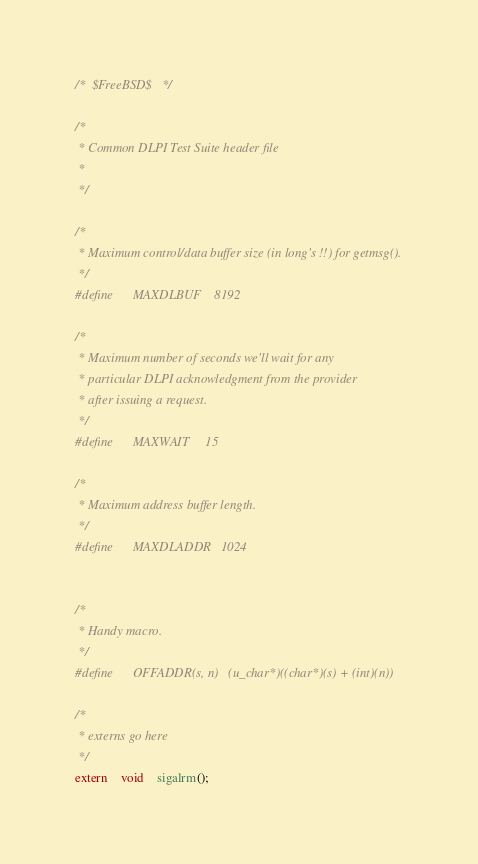<code> <loc_0><loc_0><loc_500><loc_500><_C_>/*	$FreeBSD$	*/

/*
 * Common DLPI Test Suite header file
 *
 */

/*
 * Maximum control/data buffer size (in long's !!) for getmsg().
 */
#define		MAXDLBUF	8192

/*
 * Maximum number of seconds we'll wait for any
 * particular DLPI acknowledgment from the provider
 * after issuing a request.
 */
#define		MAXWAIT		15

/*
 * Maximum address buffer length.
 */
#define		MAXDLADDR	1024


/*
 * Handy macro.
 */
#define		OFFADDR(s, n)	(u_char*)((char*)(s) + (int)(n))

/*
 * externs go here
 */
extern	void	sigalrm();
</code> 